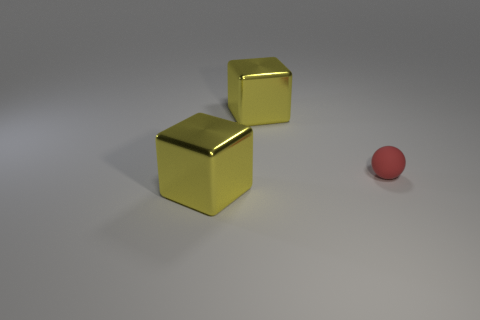Add 3 small rubber cubes. How many objects exist? 6 Subtract all balls. How many objects are left? 2 Subtract 0 cyan cubes. How many objects are left? 3 Subtract all matte things. Subtract all tiny gray metallic spheres. How many objects are left? 2 Add 3 large shiny blocks. How many large shiny blocks are left? 5 Add 3 tiny brown metal blocks. How many tiny brown metal blocks exist? 3 